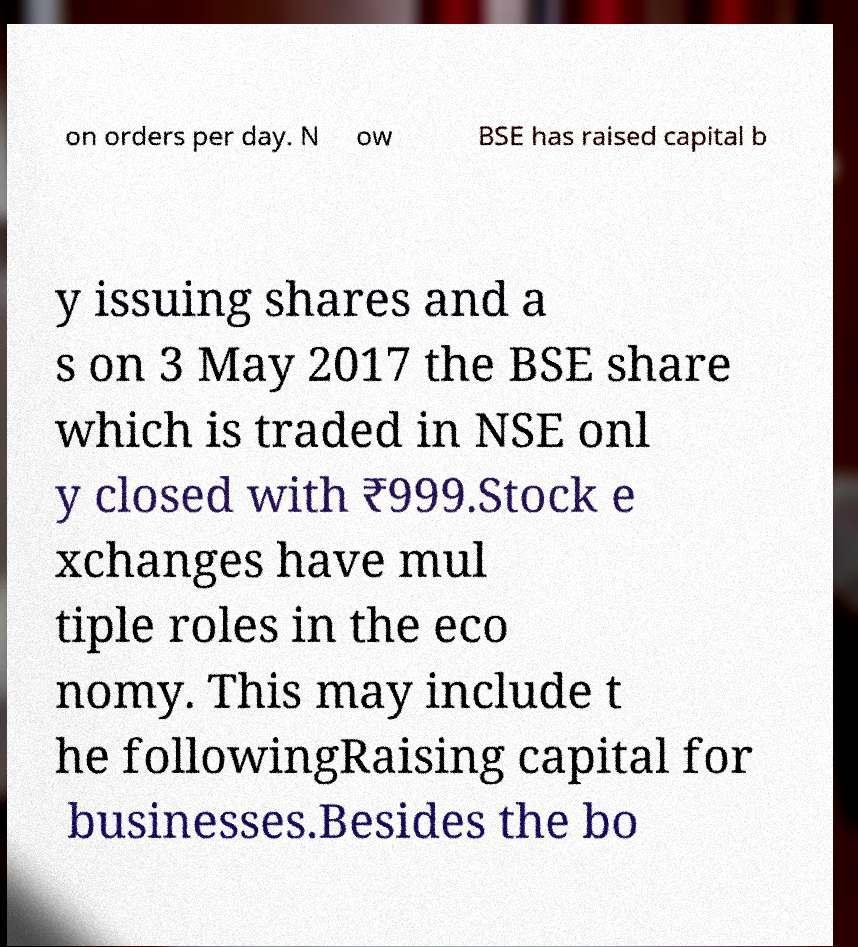Could you extract and type out the text from this image? on orders per day. N ow BSE has raised capital b y issuing shares and a s on 3 May 2017 the BSE share which is traded in NSE onl y closed with ₹999.Stock e xchanges have mul tiple roles in the eco nomy. This may include t he followingRaising capital for businesses.Besides the bo 